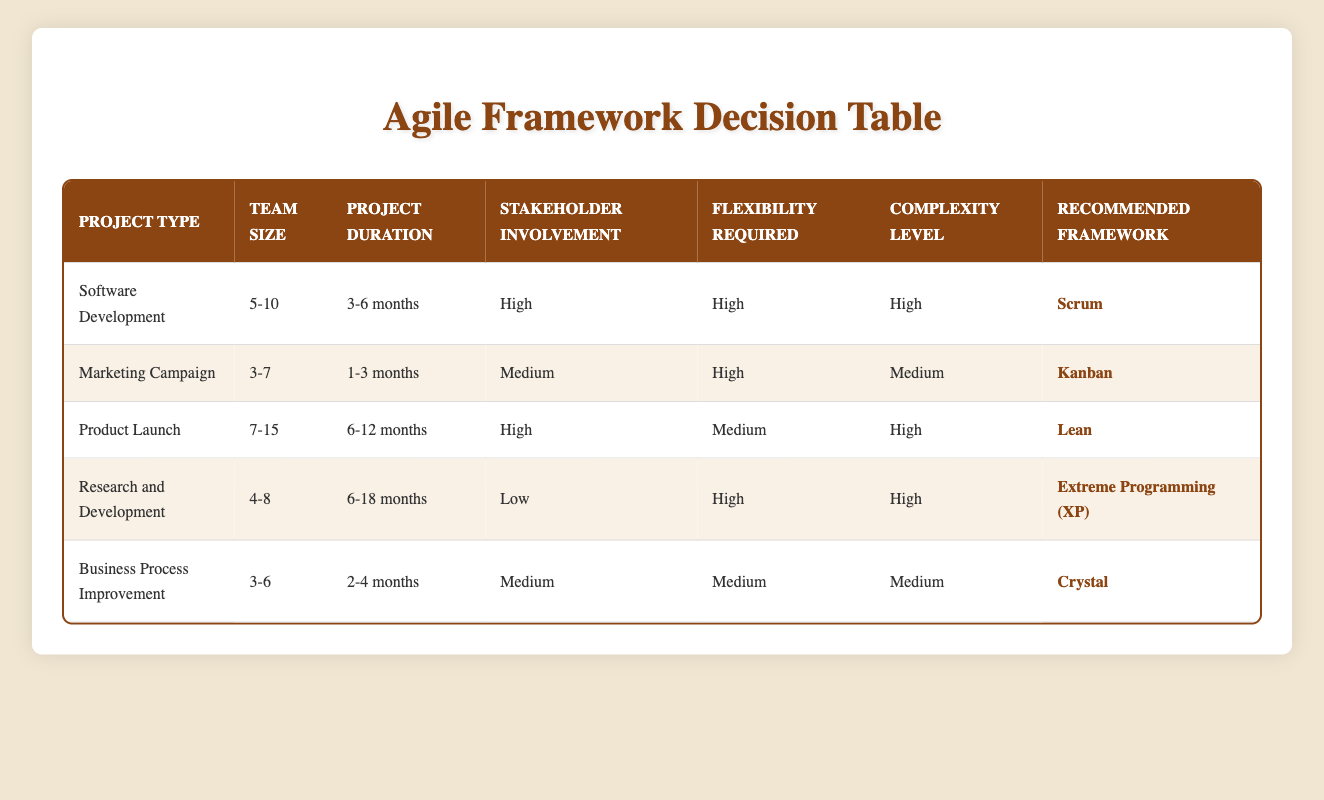What agile framework is recommended for Software Development? The table explicitly states that the recommended framework for Software Development is Scrum.
Answer: Scrum What is the team size range for a Marketing Campaign project? The table indicates that the team size range for a Marketing Campaign project is 3-7.
Answer: 3-7 Which project type requires High complexity and has Low stakeholder involvement? From the table, the Research and Development project type is characterized by High complexity and Low stakeholder involvement.
Answer: Research and Development What is the average project duration for Product Launch and Business Process Improvement? The project duration for Product Launch is 6-12 months, and for Business Process Improvement, it is 2-4 months. If we take the average of these ranges, Product Launch averages 9 months and Business Process Improvement averages 3 months. Adding 9 and 3 gives 12 months, and dividing by the number of projects (2) gives (12 / 2 = 6).
Answer: 6 months Is Kanban recommended for projects with a team size of 7-15? The table shows that Kanban is recommended for Marketing Campaigns, which have a smaller team size of 3-7. Hence, it is not suitable for projects with a team size of 7-15 because Kanban is not listed for such projects.
Answer: No How many project types require High flexibility? The table details that there are three project types requiring High flexibility: Software Development, Marketing Campaign, and Research and Development. Counting these gives a total of three project types.
Answer: 3 Which agile framework is suitable for a project with Medium flexibility? The table specifies that both Business Process Improvement and Product Launch projects require Medium flexibility, with Crystal and Lean recommended frameworks, respectively.
Answer: Crystal and Lean Which project type has the highest recommended team size? From the table, the Product Launch project type has the highest recommended team size, which is between 7-15.
Answer: Product Launch What are the complexities present in projects that require the Scrum framework? According to the table, Scrum is recommended for Software Development, which has High complexity. Thus, the complexity present in projects using Scrum is High.
Answer: High 